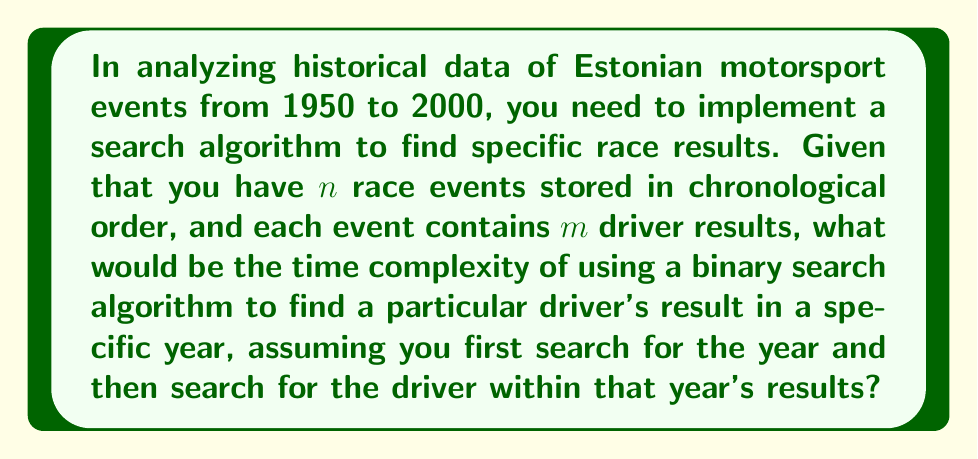What is the answer to this math problem? Let's break this down step by step:

1. First, we need to search for the specific year among $n$ race events. Since the events are stored in chronological order, we can use binary search for this step.
   - The time complexity of binary search is $O(\log n)$

2. Once we find the correct year, we need to search for the specific driver among $m$ driver results for that year. If the driver results are not sorted, we would need to perform a linear search.
   - The time complexity of linear search is $O(m)$

3. Combining these steps:
   - We perform a binary search on $n$ events: $O(\log n)$
   - Followed by a linear search on $m$ drivers: $O(m)$

4. The total time complexity is the sum of these two steps:
   $$O(\log n + m)$$

5. However, in Big O notation, we typically express the complexity in terms of the input size. In this case, the total input size is $n \cdot m$ (total number of driver results across all events).

6. In the worst case, $m$ could be as large as $n$, so we can't simplify this further without additional information about the relationship between $n$ and $m$.

Therefore, the overall time complexity remains $O(\log n + m)$.
Answer: $O(\log n + m)$, where $n$ is the number of race events and $m$ is the number of driver results per event. 